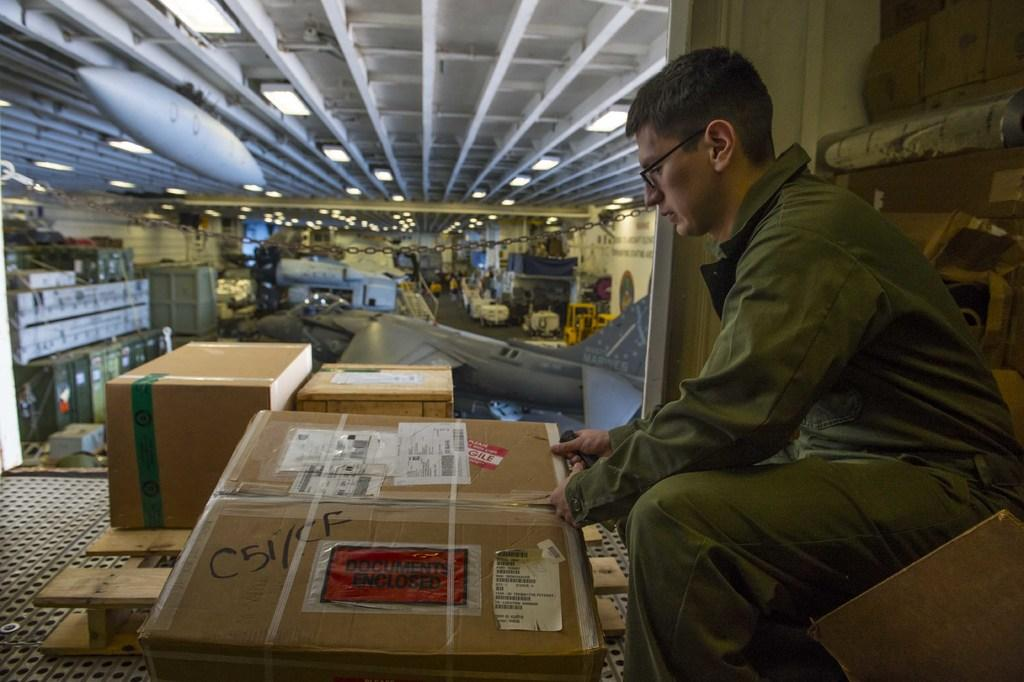Provide a one-sentence caption for the provided image. A man is opening a box that has C51/CF written in black marker on it. 